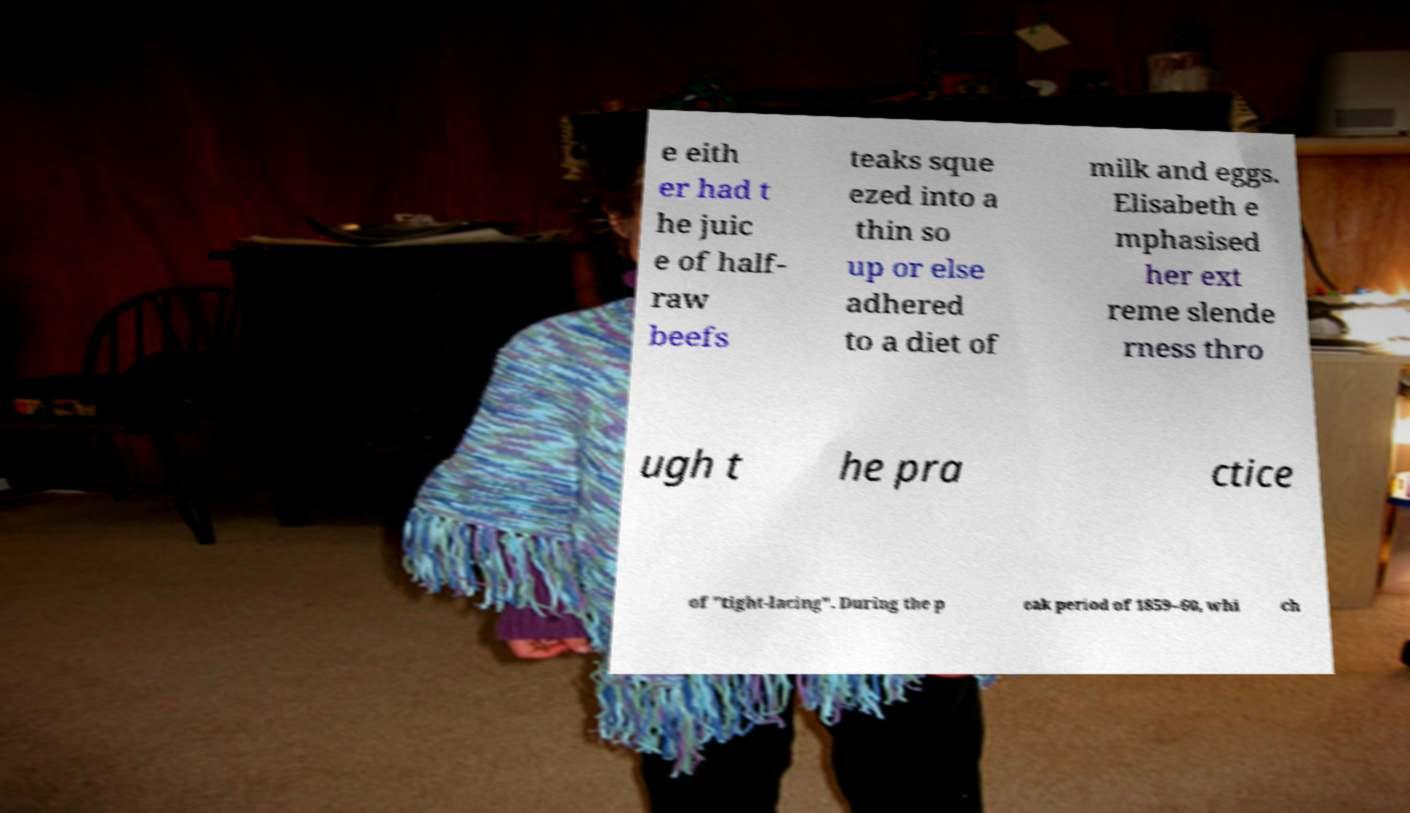What messages or text are displayed in this image? I need them in a readable, typed format. e eith er had t he juic e of half- raw beefs teaks sque ezed into a thin so up or else adhered to a diet of milk and eggs. Elisabeth e mphasised her ext reme slende rness thro ugh t he pra ctice of "tight-lacing". During the p eak period of 1859–60, whi ch 